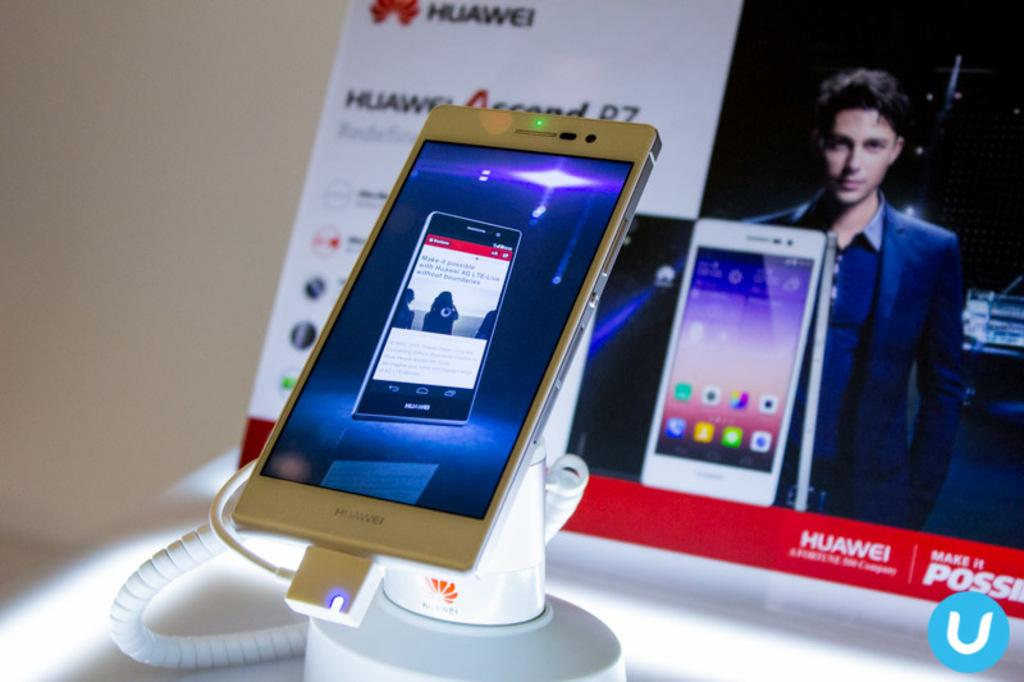<image>
Provide a brief description of the given image. A phone from the company Huawei in front of an ad 